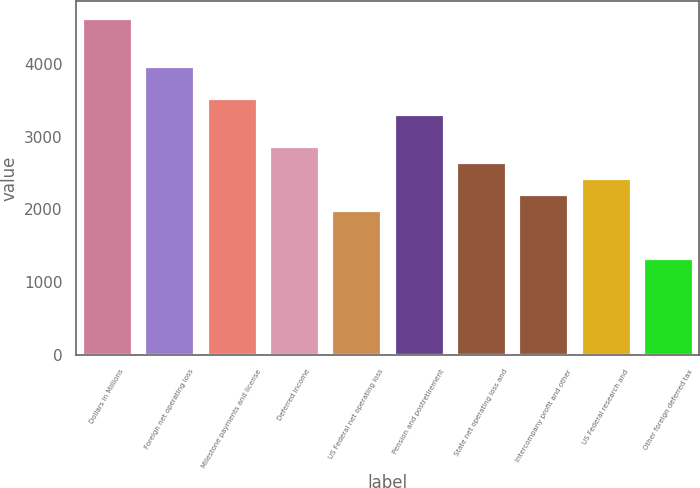Convert chart to OTSL. <chart><loc_0><loc_0><loc_500><loc_500><bar_chart><fcel>Dollars in Millions<fcel>Foreign net operating loss<fcel>Milestone payments and license<fcel>Deferred income<fcel>US Federal net operating loss<fcel>Pension and postretirement<fcel>State net operating loss and<fcel>Intercompany profit and other<fcel>US Federal research and<fcel>Other foreign deferred tax<nl><fcel>4628<fcel>3968<fcel>3528<fcel>2868<fcel>1988<fcel>3308<fcel>2648<fcel>2208<fcel>2428<fcel>1328<nl></chart> 